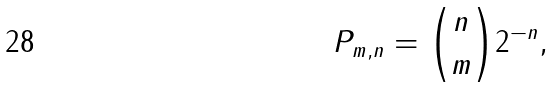<formula> <loc_0><loc_0><loc_500><loc_500>P _ { m , n } = { \binom { n } { m } } 2 ^ { - n } ,</formula> 